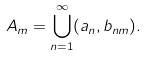<formula> <loc_0><loc_0><loc_500><loc_500>A _ { m } = \bigcup _ { n = 1 } ^ { \infty } ( a _ { n } , b _ { n m } ) .</formula> 